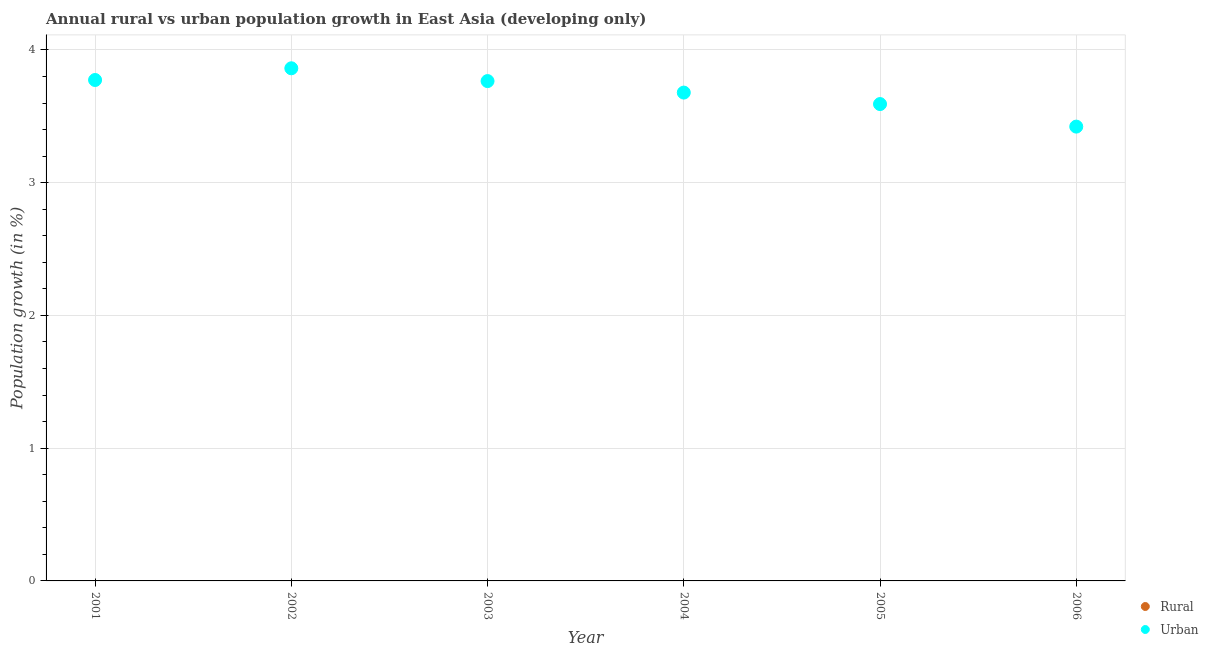Is the number of dotlines equal to the number of legend labels?
Your answer should be very brief. No. What is the urban population growth in 2001?
Provide a succinct answer. 3.77. Across all years, what is the minimum rural population growth?
Keep it short and to the point. 0. In which year was the urban population growth maximum?
Your response must be concise. 2002. What is the total rural population growth in the graph?
Provide a succinct answer. 0. What is the difference between the urban population growth in 2002 and that in 2006?
Give a very brief answer. 0.44. What is the difference between the urban population growth in 2003 and the rural population growth in 2001?
Your answer should be compact. 3.77. What is the average rural population growth per year?
Offer a very short reply. 0. What is the ratio of the urban population growth in 2002 to that in 2005?
Your response must be concise. 1.08. Is the urban population growth in 2001 less than that in 2003?
Give a very brief answer. No. What is the difference between the highest and the second highest urban population growth?
Your response must be concise. 0.09. What is the difference between the highest and the lowest urban population growth?
Ensure brevity in your answer.  0.44. Is the urban population growth strictly greater than the rural population growth over the years?
Offer a very short reply. Yes. Is the rural population growth strictly less than the urban population growth over the years?
Make the answer very short. Yes. How many dotlines are there?
Provide a succinct answer. 1. How many years are there in the graph?
Your answer should be compact. 6. Does the graph contain grids?
Ensure brevity in your answer.  Yes. Where does the legend appear in the graph?
Your response must be concise. Bottom right. How many legend labels are there?
Make the answer very short. 2. What is the title of the graph?
Your answer should be compact. Annual rural vs urban population growth in East Asia (developing only). Does "Investment" appear as one of the legend labels in the graph?
Offer a terse response. No. What is the label or title of the Y-axis?
Offer a terse response. Population growth (in %). What is the Population growth (in %) of Urban  in 2001?
Ensure brevity in your answer.  3.77. What is the Population growth (in %) of Rural in 2002?
Keep it short and to the point. 0. What is the Population growth (in %) of Urban  in 2002?
Ensure brevity in your answer.  3.86. What is the Population growth (in %) of Urban  in 2003?
Your answer should be very brief. 3.77. What is the Population growth (in %) in Urban  in 2004?
Your response must be concise. 3.68. What is the Population growth (in %) in Urban  in 2005?
Your answer should be compact. 3.59. What is the Population growth (in %) of Rural in 2006?
Give a very brief answer. 0. What is the Population growth (in %) of Urban  in 2006?
Ensure brevity in your answer.  3.42. Across all years, what is the maximum Population growth (in %) of Urban ?
Give a very brief answer. 3.86. Across all years, what is the minimum Population growth (in %) in Urban ?
Give a very brief answer. 3.42. What is the total Population growth (in %) of Urban  in the graph?
Your answer should be very brief. 22.1. What is the difference between the Population growth (in %) of Urban  in 2001 and that in 2002?
Ensure brevity in your answer.  -0.09. What is the difference between the Population growth (in %) in Urban  in 2001 and that in 2003?
Ensure brevity in your answer.  0.01. What is the difference between the Population growth (in %) in Urban  in 2001 and that in 2004?
Keep it short and to the point. 0.09. What is the difference between the Population growth (in %) of Urban  in 2001 and that in 2005?
Keep it short and to the point. 0.18. What is the difference between the Population growth (in %) of Urban  in 2001 and that in 2006?
Give a very brief answer. 0.35. What is the difference between the Population growth (in %) of Urban  in 2002 and that in 2003?
Keep it short and to the point. 0.1. What is the difference between the Population growth (in %) in Urban  in 2002 and that in 2004?
Provide a short and direct response. 0.18. What is the difference between the Population growth (in %) in Urban  in 2002 and that in 2005?
Your answer should be compact. 0.27. What is the difference between the Population growth (in %) of Urban  in 2002 and that in 2006?
Ensure brevity in your answer.  0.44. What is the difference between the Population growth (in %) of Urban  in 2003 and that in 2004?
Provide a short and direct response. 0.09. What is the difference between the Population growth (in %) of Urban  in 2003 and that in 2005?
Provide a short and direct response. 0.17. What is the difference between the Population growth (in %) of Urban  in 2003 and that in 2006?
Your response must be concise. 0.34. What is the difference between the Population growth (in %) of Urban  in 2004 and that in 2005?
Offer a very short reply. 0.09. What is the difference between the Population growth (in %) of Urban  in 2004 and that in 2006?
Your answer should be compact. 0.26. What is the difference between the Population growth (in %) of Urban  in 2005 and that in 2006?
Ensure brevity in your answer.  0.17. What is the average Population growth (in %) of Rural per year?
Your answer should be very brief. 0. What is the average Population growth (in %) in Urban  per year?
Provide a short and direct response. 3.68. What is the ratio of the Population growth (in %) of Urban  in 2001 to that in 2002?
Keep it short and to the point. 0.98. What is the ratio of the Population growth (in %) of Urban  in 2001 to that in 2004?
Provide a succinct answer. 1.03. What is the ratio of the Population growth (in %) of Urban  in 2001 to that in 2005?
Offer a terse response. 1.05. What is the ratio of the Population growth (in %) in Urban  in 2001 to that in 2006?
Offer a very short reply. 1.1. What is the ratio of the Population growth (in %) of Urban  in 2002 to that in 2003?
Your answer should be very brief. 1.03. What is the ratio of the Population growth (in %) of Urban  in 2002 to that in 2004?
Your answer should be compact. 1.05. What is the ratio of the Population growth (in %) in Urban  in 2002 to that in 2005?
Your answer should be compact. 1.07. What is the ratio of the Population growth (in %) of Urban  in 2002 to that in 2006?
Give a very brief answer. 1.13. What is the ratio of the Population growth (in %) in Urban  in 2003 to that in 2004?
Ensure brevity in your answer.  1.02. What is the ratio of the Population growth (in %) of Urban  in 2003 to that in 2005?
Provide a short and direct response. 1.05. What is the ratio of the Population growth (in %) of Urban  in 2003 to that in 2006?
Your answer should be very brief. 1.1. What is the ratio of the Population growth (in %) in Urban  in 2004 to that in 2005?
Ensure brevity in your answer.  1.02. What is the ratio of the Population growth (in %) in Urban  in 2004 to that in 2006?
Give a very brief answer. 1.07. What is the ratio of the Population growth (in %) of Urban  in 2005 to that in 2006?
Make the answer very short. 1.05. What is the difference between the highest and the second highest Population growth (in %) in Urban ?
Your response must be concise. 0.09. What is the difference between the highest and the lowest Population growth (in %) of Urban ?
Give a very brief answer. 0.44. 